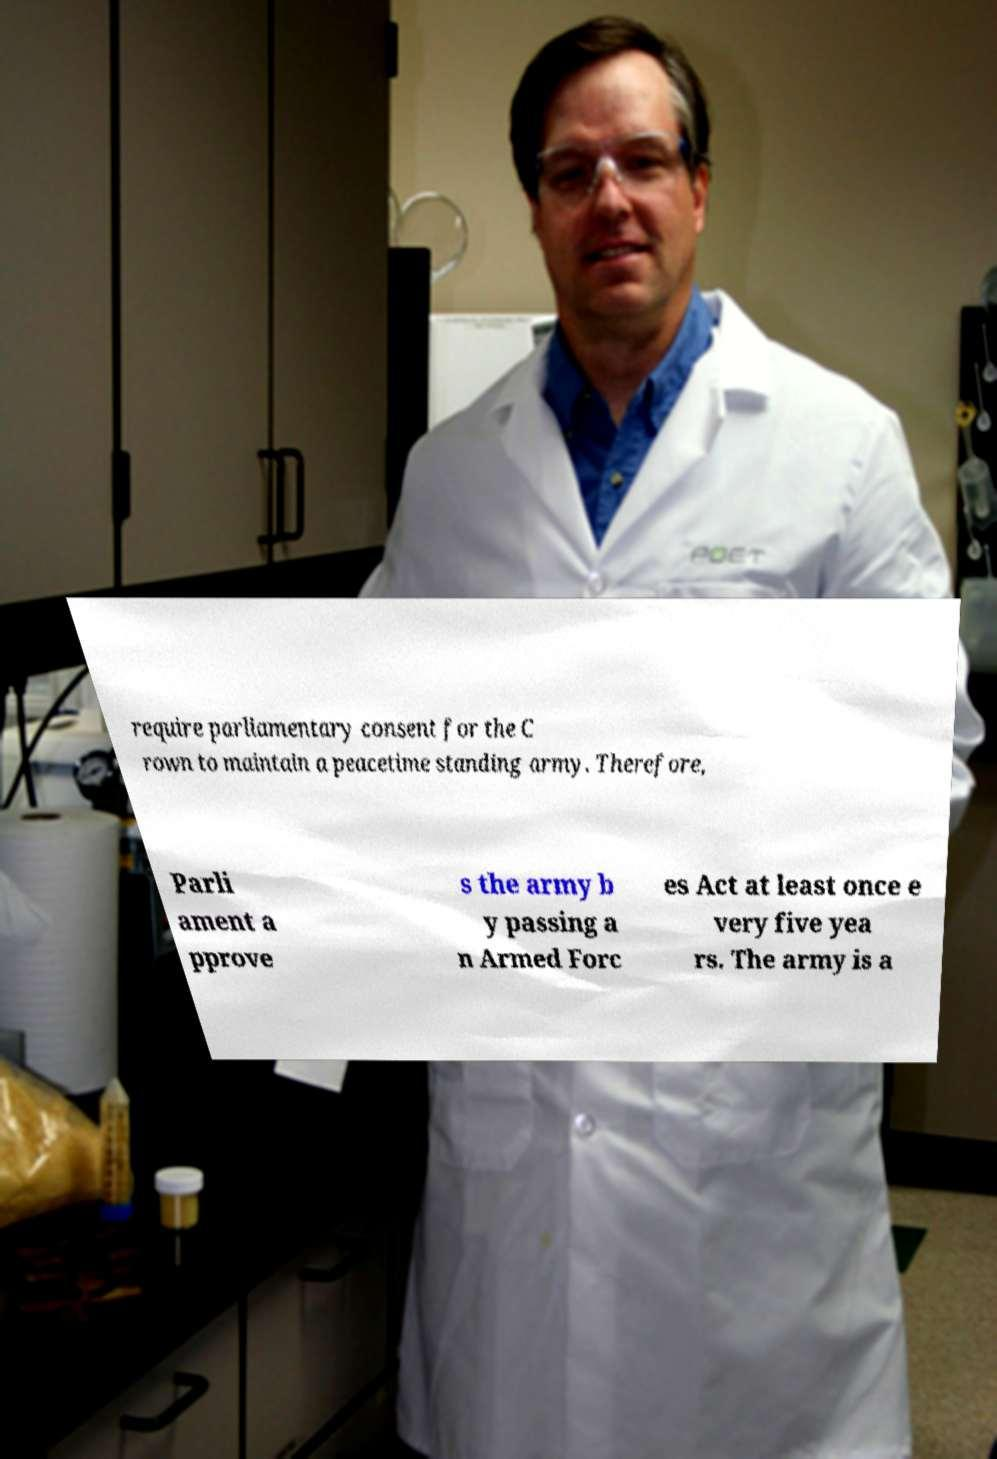What messages or text are displayed in this image? I need them in a readable, typed format. require parliamentary consent for the C rown to maintain a peacetime standing army. Therefore, Parli ament a pprove s the army b y passing a n Armed Forc es Act at least once e very five yea rs. The army is a 